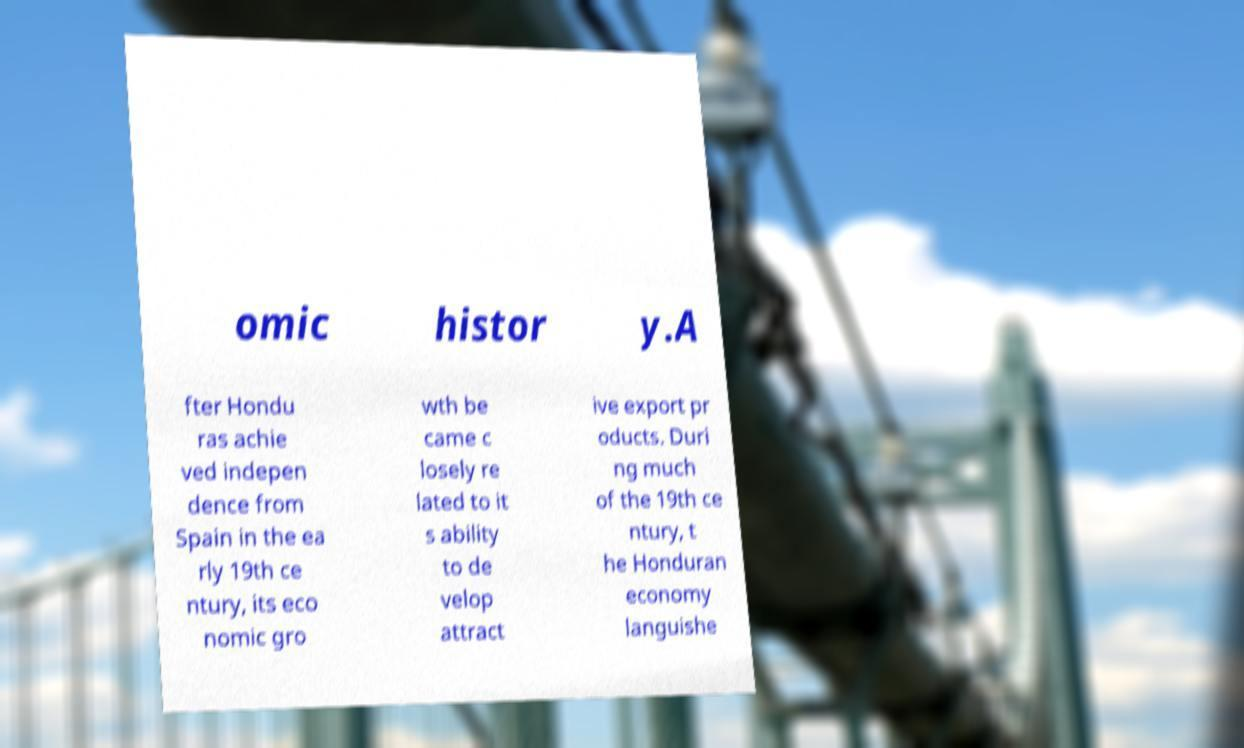What messages or text are displayed in this image? I need them in a readable, typed format. omic histor y.A fter Hondu ras achie ved indepen dence from Spain in the ea rly 19th ce ntury, its eco nomic gro wth be came c losely re lated to it s ability to de velop attract ive export pr oducts. Duri ng much of the 19th ce ntury, t he Honduran economy languishe 